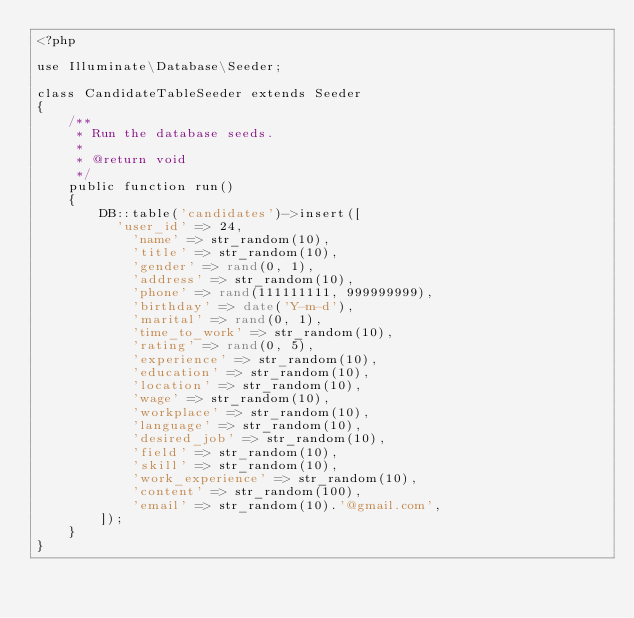<code> <loc_0><loc_0><loc_500><loc_500><_PHP_><?php

use Illuminate\Database\Seeder;

class CandidateTableSeeder extends Seeder
{
    /**
     * Run the database seeds.
     *
     * @return void
     */
    public function run()
    {
        DB::table('candidates')->insert([
        	'user_id' => 24,
            'name' => str_random(10),
            'title' => str_random(10),
            'gender' => rand(0, 1),
            'address' => str_random(10),
            'phone' => rand(111111111, 999999999),
            'birthday' => date('Y-m-d'),
            'marital' => rand(0, 1),
            'time_to_work' => str_random(10),
            'rating' => rand(0, 5),
            'experience' => str_random(10),
            'education' => str_random(10),
            'location' => str_random(10),
            'wage' => str_random(10),
            'workplace' => str_random(10),
            'language' => str_random(10),
            'desired_job' => str_random(10),
            'field' => str_random(10),
            'skill' => str_random(10),
            'work_experience' => str_random(10),
            'content' => str_random(100),
            'email' => str_random(10).'@gmail.com',
        ]);
    }
}
</code> 